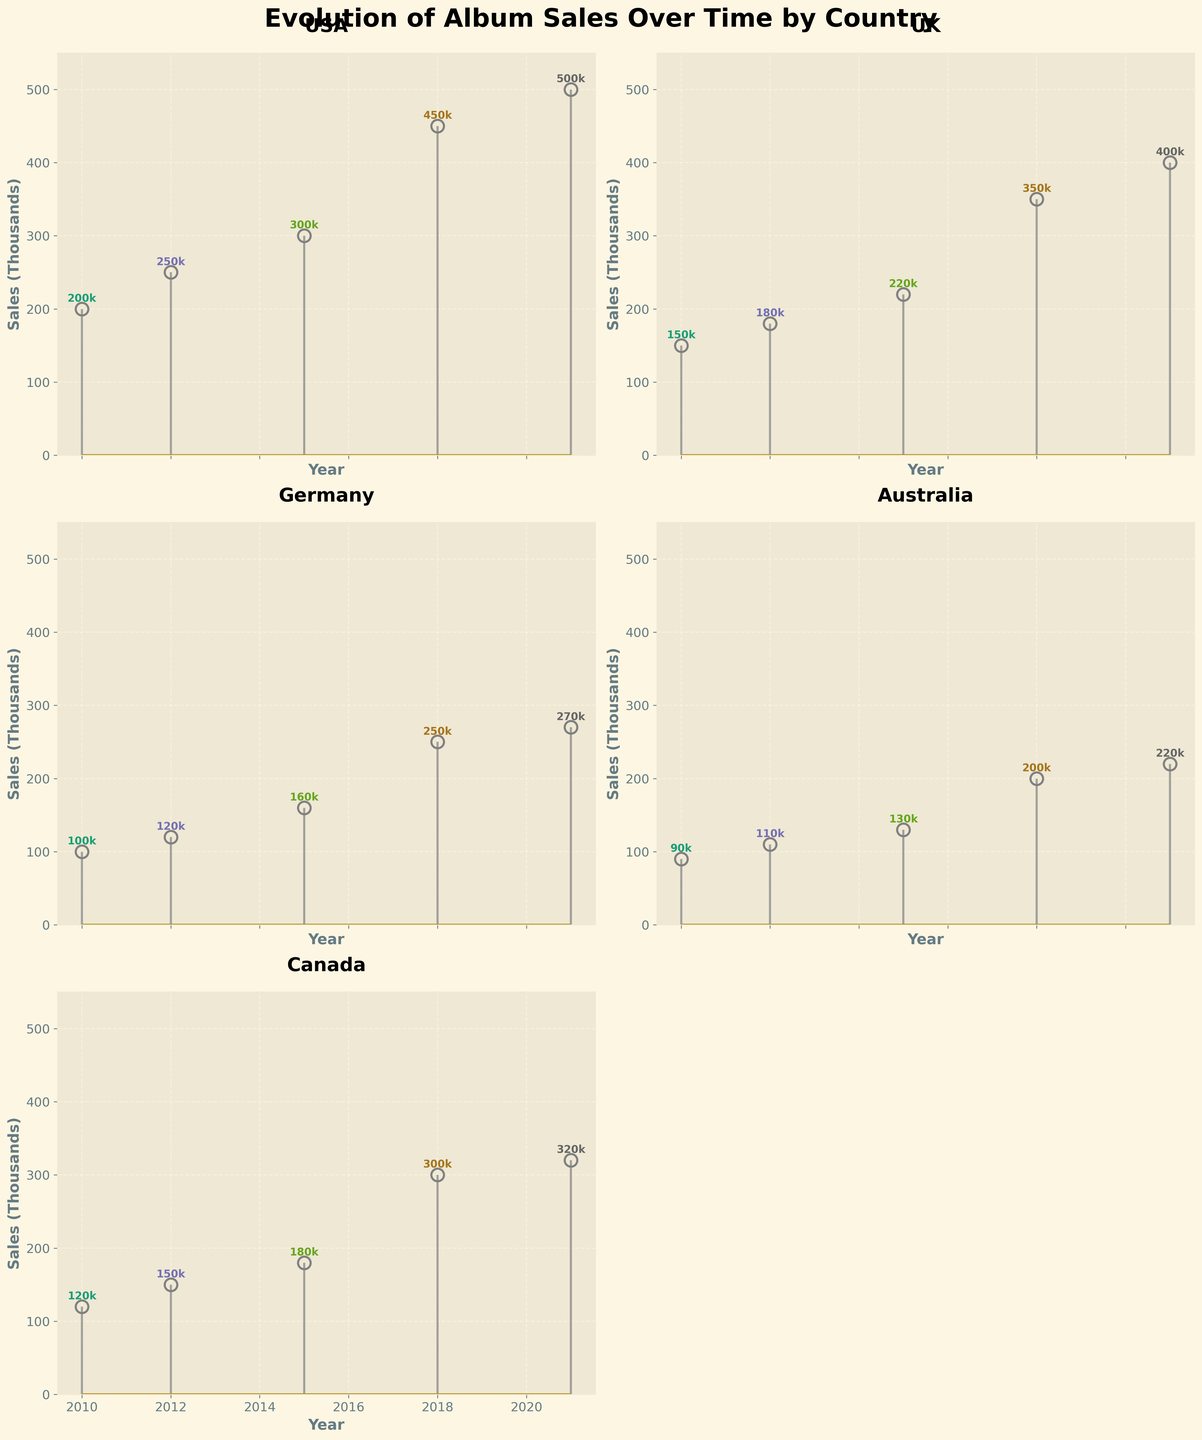Which country has the highest album sales in 2021? By looking at the USA subplot, the sales value in 2021 is 500k, which is the highest among all other subplots for the same year.
Answer: USA What is the general trend of album sales in Germany from 2010 to 2021? The plot for Germany shows an increasing trend in album sales from 100k in 2010 to 270k in 2021.
Answer: Increasing Which two countries have the largest difference in sales for the Fifth Album in 2021? In 2021, the USA has 500k and Australia has 220k. The difference between USA and Australia is the largest, which is 280k (500k - 220k).
Answer: USA and Australia Which album sales show a noticeable spike among countries in 2018? The subplot for the UK shows a noticeable spike in album sales from 220k in 2015 to 350k in 2018.
Answer: UK Counting data points from all subplots, how many albums are there in total? Each country subplot contains 5 data points representing the five albums released. There are 5 countries, resulting in a total of 5 * 5 = 25 data points.
Answer: 25 Compare the album sales trend in the UK and Canada. Which country shows a steeper increase? From 2010 to 2021, the UK's increase in album sales (150k to 400k) suggests a rise by 250k, while Canada's increase (120k to 320k) suggests a rise by 200k. UK's increase is steeper.
Answer: UK What is the range of album sales in Australia? The range is calculated by subtracting the smallest value from the largest. In Australia, the lowest album sales are 90k and the highest are 220k, so the range is 220k - 90k = 130k.
Answer: 130k Which subplot appears to have the most evenly spaced values? Examining visually, the album sales for Australia have relatively even spacing between values: 90k, 110k, 130k, 200k, and 220k, with no drastic jumps.
Answer: Australia How does the Fourth Album (2018) sales in Canada compare to the Debut Album (2010) sales in the USA? The Canadian Fourth Album sales in 2018 are 300k, while the USA Debut Album in 2010 is 200k. Therefore, Canada's Fourth Album sales are higher by 100k.
Answer: 100k higher What is the average album sales in the UK? Add up the sales values in the UK (150k + 180k + 220k + 350k + 400k) which equals 1300k, then divide by the number of years (5), resulting in an average of 1300k / 5 = 260k.
Answer: 260k 